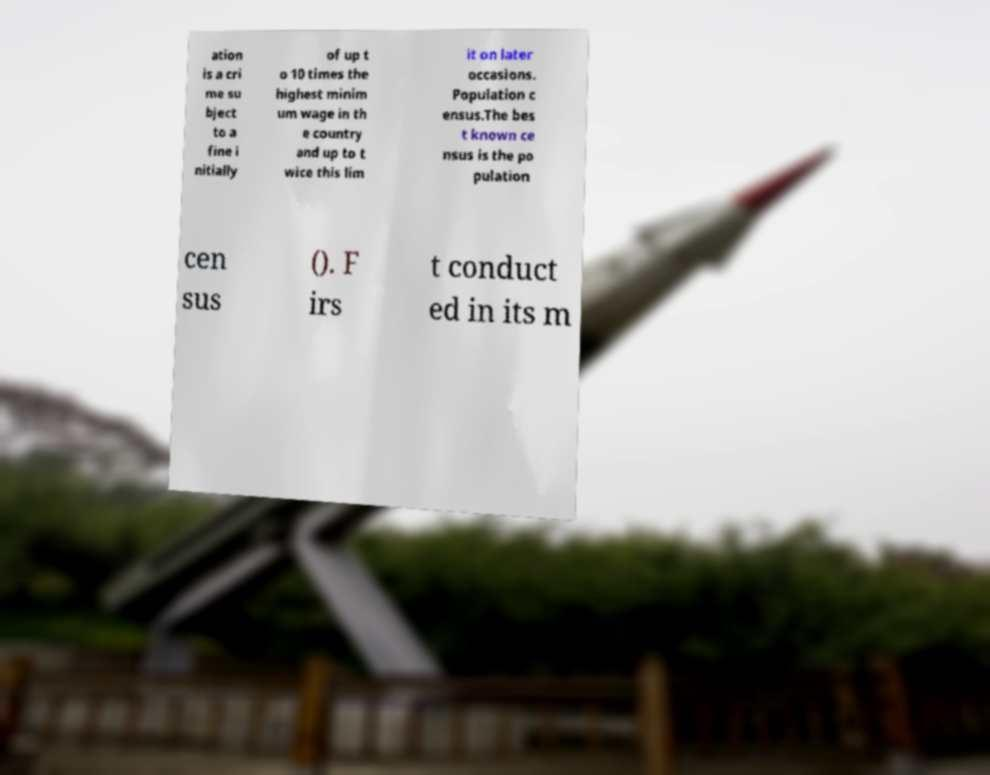I need the written content from this picture converted into text. Can you do that? ation is a cri me su bject to a fine i nitially of up t o 10 times the highest minim um wage in th e country and up to t wice this lim it on later occasions. Population c ensus.The bes t known ce nsus is the po pulation cen sus (). F irs t conduct ed in its m 